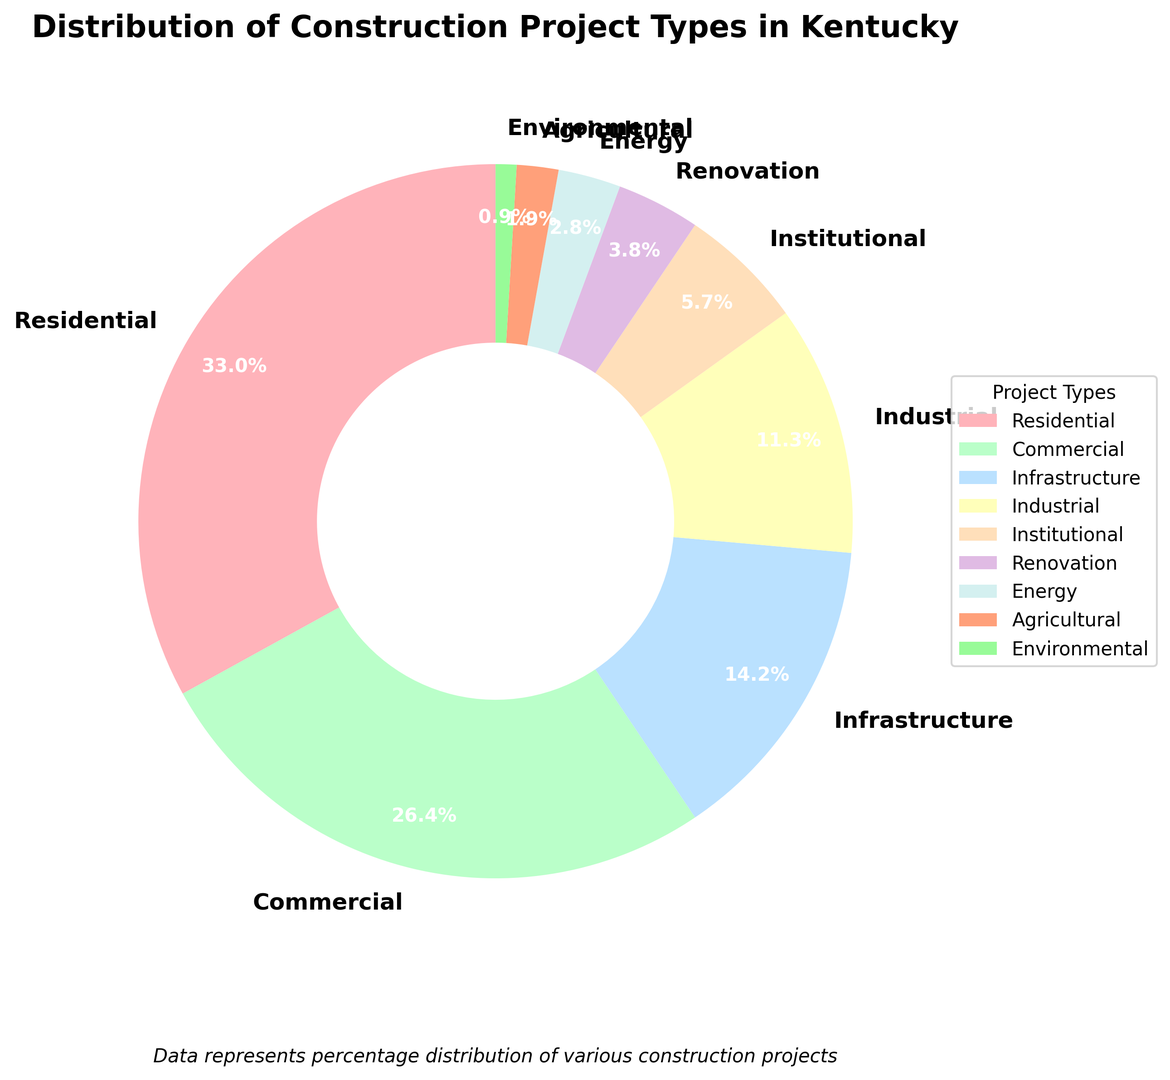What percentage of projects are Residential or Commercial? The Residential projects make up 35% and the Commercial projects make up 28%. Adding these two percentages together, 35% + 28%, gives us the total percentage.
Answer: 63% Which project type has the smallest percentage? By observing the distribution, the project type with the smallest percentage is Environmental with 1%.
Answer: Environmental How many project types have a percentage greater than 10%? From the chart, Residential, Commercial, Infrastructure, and Industrial project types all have percentages greater than 10%. This totals to four project types.
Answer: 4 What’s the difference in percentage between Infrastructure and Renovation projects? The Infrastructure projects make up 15% and Renovation projects make up 4%. Subtracting these two percentages, 15% - 4%, gives us the difference.
Answer: 11% Which project type occupies the third largest portion of the pie chart? Observing the chart, the Residential (35%) is the largest, Commercial (28%) is the second largest, and Infrastructure (15%) is the third largest.
Answer: Infrastructure Are Institutional projects more or less common than Energy projects? Institutional projects make up 6% while Energy projects make up 3%. Since 6% is greater than 3%, Institutional projects are more common.
Answer: More What is the combined percentage of Institutional and Environmental projects? Institutional projects are 6% and Environmental projects are 1%. Adding these two percentages together, 6% + 1%, gives us the total percentage.
Answer: 7% Is the percentage share of Agricultural projects twice that of Environmental projects? Agricultural projects take up 2% and Environmental projects take up 1%. Since 2% is twice 1%, the percentage share of Agricultural projects is indeed twice that of Environmental projects.
Answer: Yes Which two project types make up less than 5% combined? The Renovation projects make up 4%, and Energy projects make up 3%. Adding these two percentages gives 4% + 3% = 7%. Therefore, none of the two projects combined are less than 5%. Actually, Agricultural (2%) and Environmental (1%) combine to make 3%, which is less than 5%.
Answer: Agricultural and Environmental 